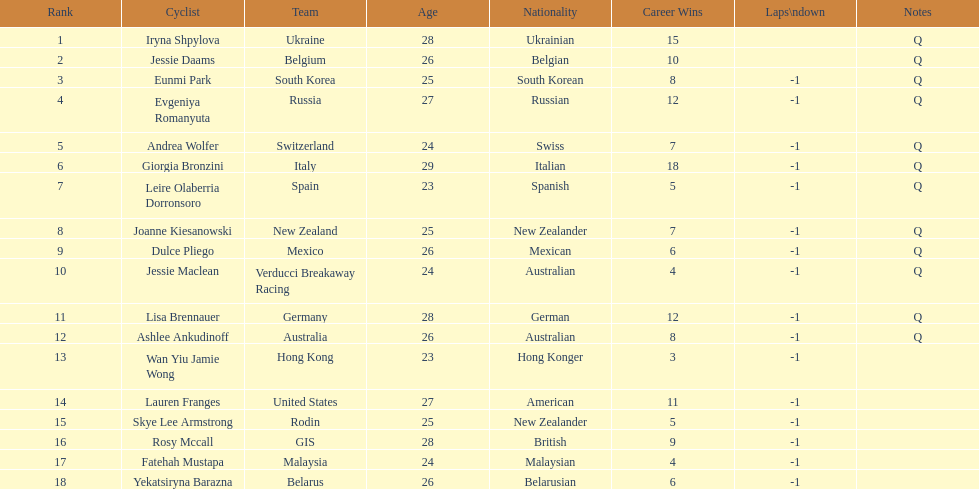What is the number of cyclists without -1 laps down? 2. 